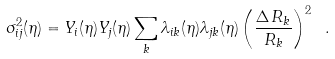Convert formula to latex. <formula><loc_0><loc_0><loc_500><loc_500>\sigma ^ { 2 } _ { i j } ( \eta ) = Y _ { i } ( \eta ) Y _ { j } ( \eta ) \sum _ { k } \lambda _ { i k } ( \eta ) \lambda _ { j k } ( \eta ) \left ( \frac { \Delta \, R _ { k } } { R _ { k } } \right ) ^ { 2 } \ .</formula> 